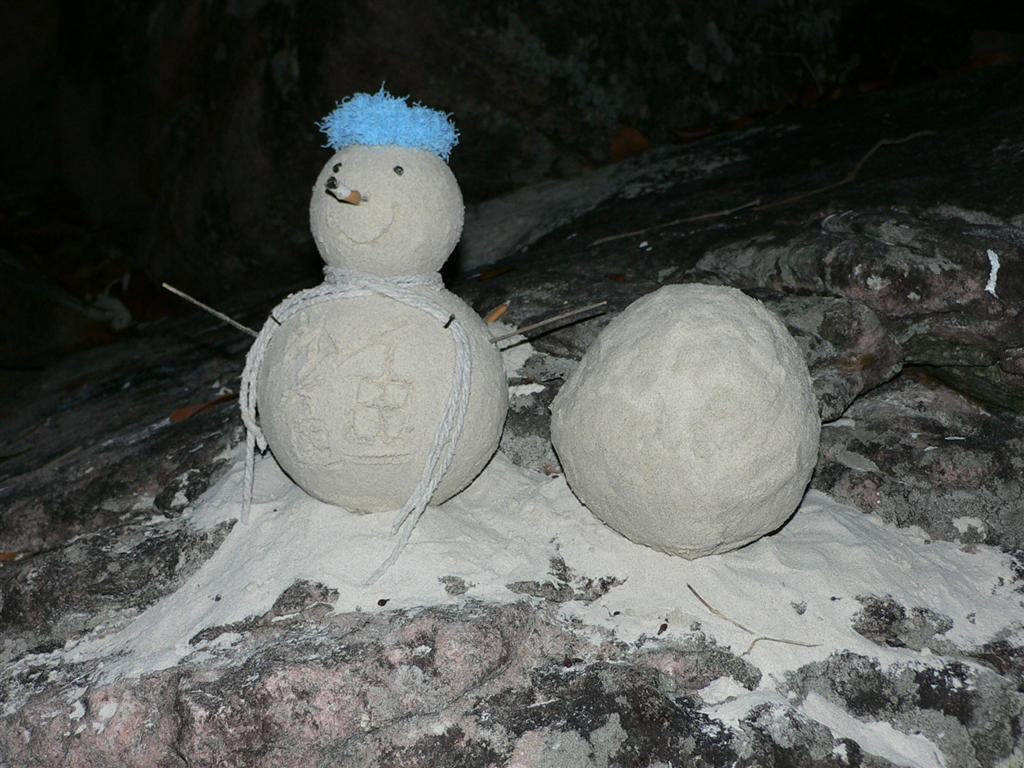What is the main subject of the image? There is a doll in the image. What other object is present with the doll? There is a concrete ball in the image. Where are the doll and concrete ball located? The doll and concrete ball are on a rock. What else can be seen in the image? There are instruments visible in the image. Can you describe the background of the image? There is another rock in the background of the image. What question is the mother asking the doll in the image? There is no mother or question present in the image; it only features a doll, a concrete ball, instruments, and rocks. How many stitches are visible on the doll's clothing in the image? There is no visible stitching on the doll's clothing in the image. 